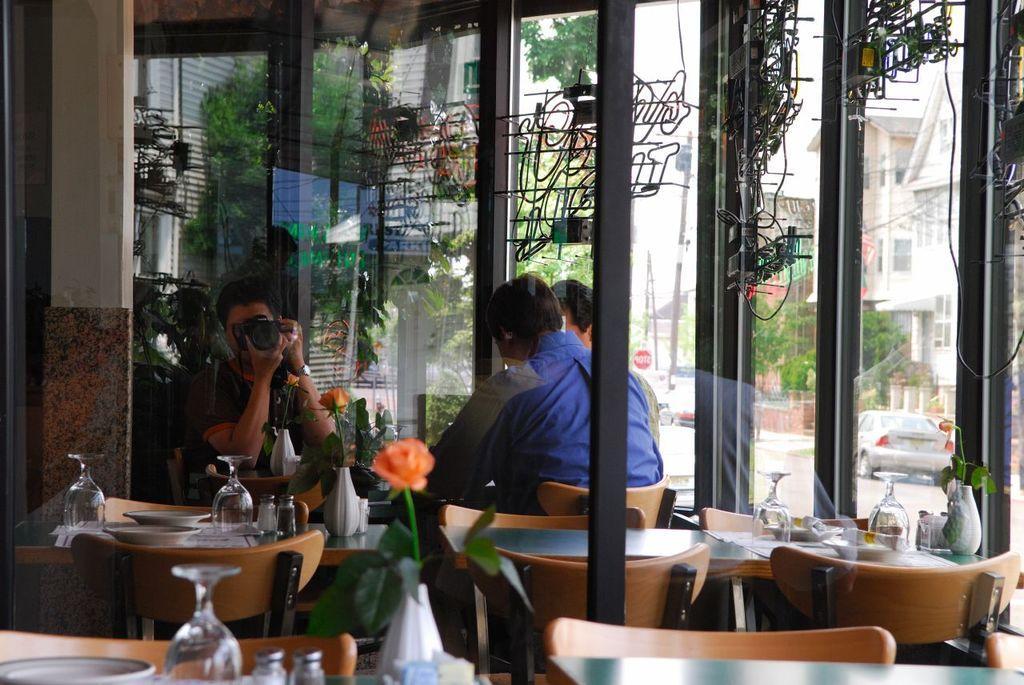How would you summarize this image in a sentence or two? In this image we can see a glass, plate and a flower on the table, and also we can see group of people seated on the chair and one person is holding a camera, in the background we can see couple of trees and couple of buildings and also we can see couple of cars on the road. 